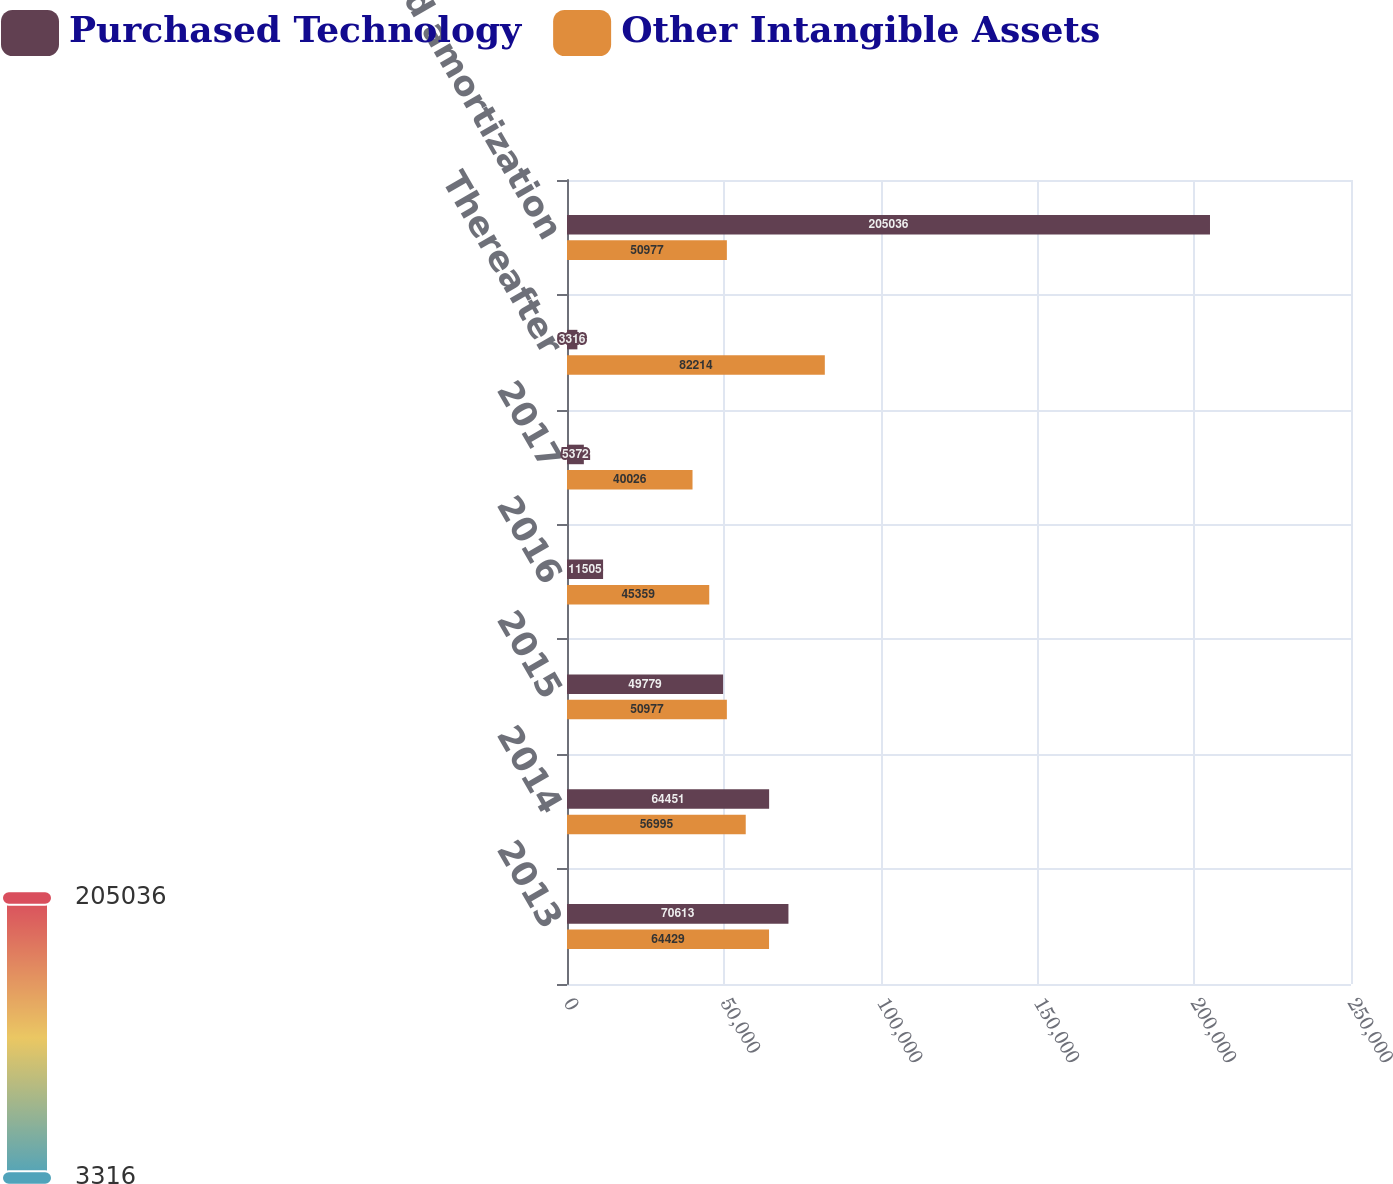Convert chart. <chart><loc_0><loc_0><loc_500><loc_500><stacked_bar_chart><ecel><fcel>2013<fcel>2014<fcel>2015<fcel>2016<fcel>2017<fcel>Thereafter<fcel>Total expected amortization<nl><fcel>Purchased Technology<fcel>70613<fcel>64451<fcel>49779<fcel>11505<fcel>5372<fcel>3316<fcel>205036<nl><fcel>Other Intangible Assets<fcel>64429<fcel>56995<fcel>50977<fcel>45359<fcel>40026<fcel>82214<fcel>50977<nl></chart> 